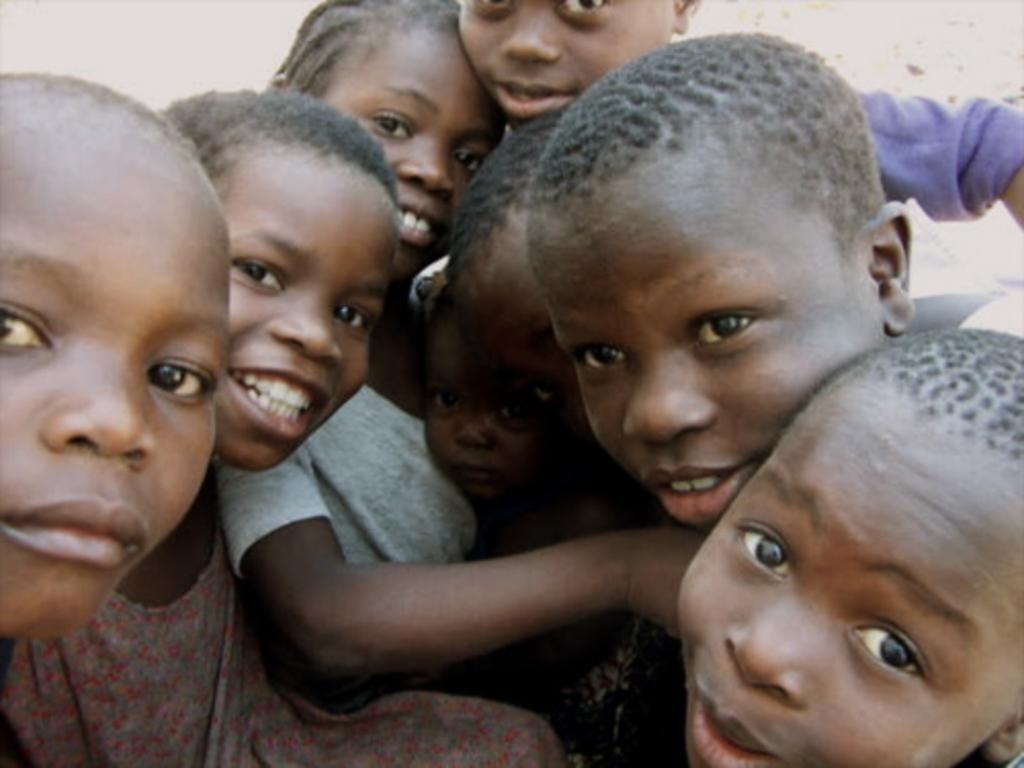Who is present in the image? There are children in the image. Where are the children located in the image? The children are in the center of the image. What type of apples are the children using to play chess in the image? There is no mention of apples or chess in the image; it only features children. How many volleyballs can be seen in the image? There is no mention of volleyballs in the image; it only features children. 